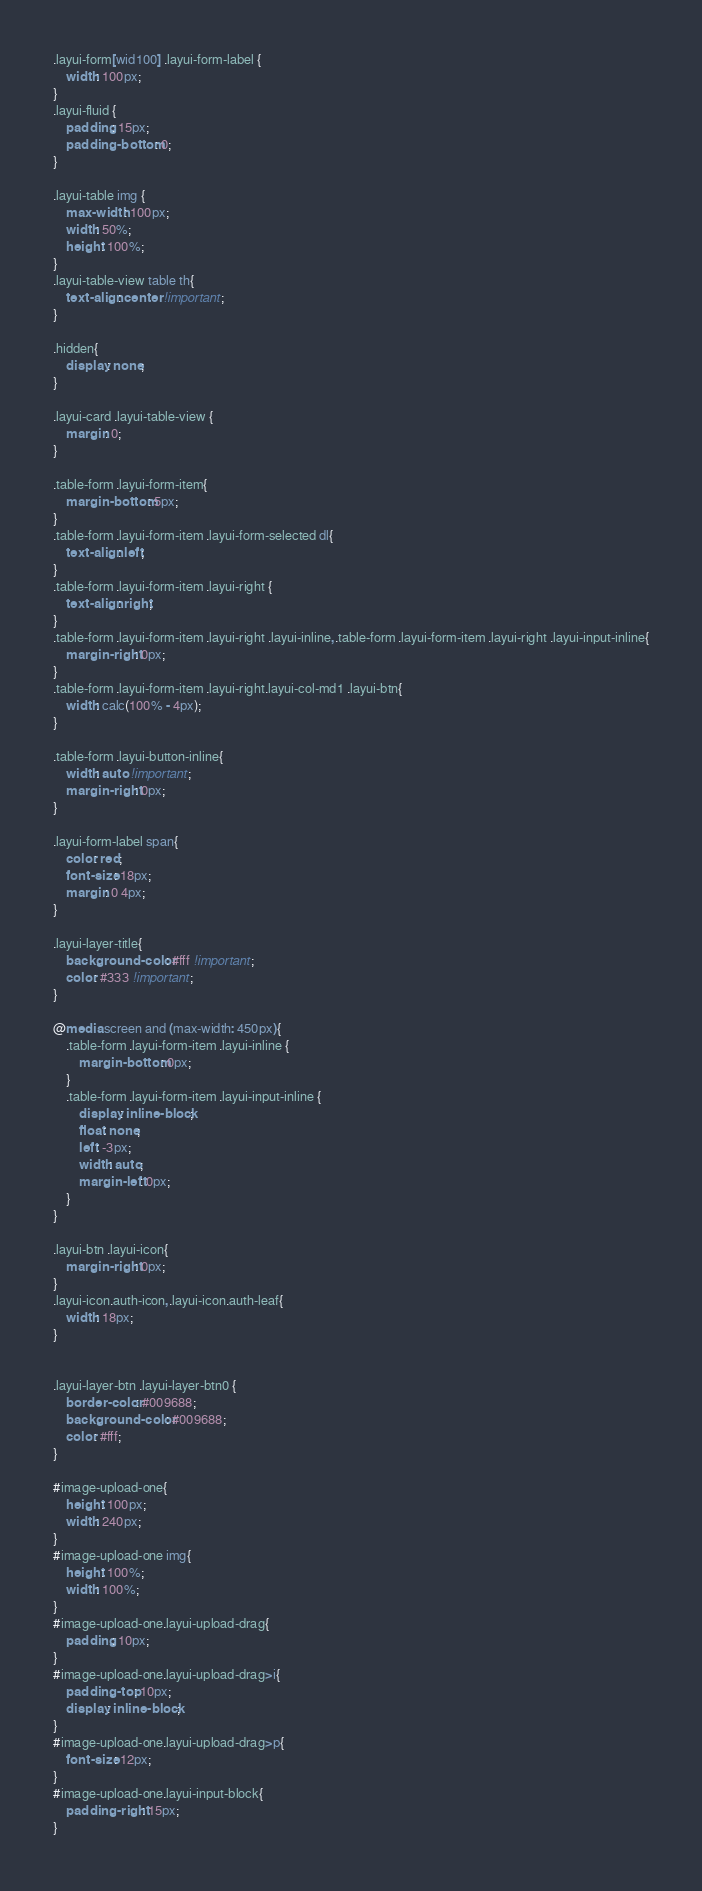<code> <loc_0><loc_0><loc_500><loc_500><_CSS_>.layui-form[wid100] .layui-form-label {
    width: 100px;
}
.layui-fluid {
    padding: 15px;
    padding-bottom: 0;
}

.layui-table img {
    max-width: 100px;
    width: 50%;
    height: 100%;
}
.layui-table-view table th{
    text-align: center !important;
}

.hidden{
    display: none;
}

.layui-card .layui-table-view {
    margin: 0;
}

.table-form .layui-form-item{
    margin-bottom: 5px;
}
.table-form .layui-form-item .layui-form-selected dl{
    text-align: left;
}
.table-form .layui-form-item .layui-right {
    text-align: right;
}
.table-form .layui-form-item .layui-right .layui-inline,.table-form .layui-form-item .layui-right .layui-input-inline{
    margin-right: 0px;
}
.table-form .layui-form-item .layui-right.layui-col-md1 .layui-btn{
    width: calc(100% - 4px);
}

.table-form .layui-button-inline{
    width: auto !important;
    margin-right: 0px;
}

.layui-form-label span{
    color: red;
    font-size: 18px;
    margin: 0 4px;
}

.layui-layer-title{
    background-color: #fff !important;
    color: #333 !important;
}

@media screen and (max-width: 450px){
    .table-form .layui-form-item .layui-inline {
        margin-bottom: 0px;
    }
    .table-form .layui-form-item .layui-input-inline {
        display: inline-block;
        float: none;
        left: -3px;
        width: auto;
        margin-left: 0px;
    }
}

.layui-btn .layui-icon{
    margin-right: 0px;
}
.layui-icon.auth-icon,.layui-icon.auth-leaf{
    width: 18px;
}


.layui-layer-btn .layui-layer-btn0 {
    border-color: #009688;
    background-color: #009688;
    color: #fff;
}

#image-upload-one{
    height: 100px;
    width: 240px;
}
#image-upload-one img{
    height: 100%;
    width: 100%;
}
#image-upload-one.layui-upload-drag{
    padding: 10px;
}
#image-upload-one.layui-upload-drag>i{
    padding-top: 10px;
    display: inline-block;
}
#image-upload-one.layui-upload-drag>p{
    font-size: 12px;
}
#image-upload-one.layui-input-block{
    padding-right: 15px;
}
</code> 